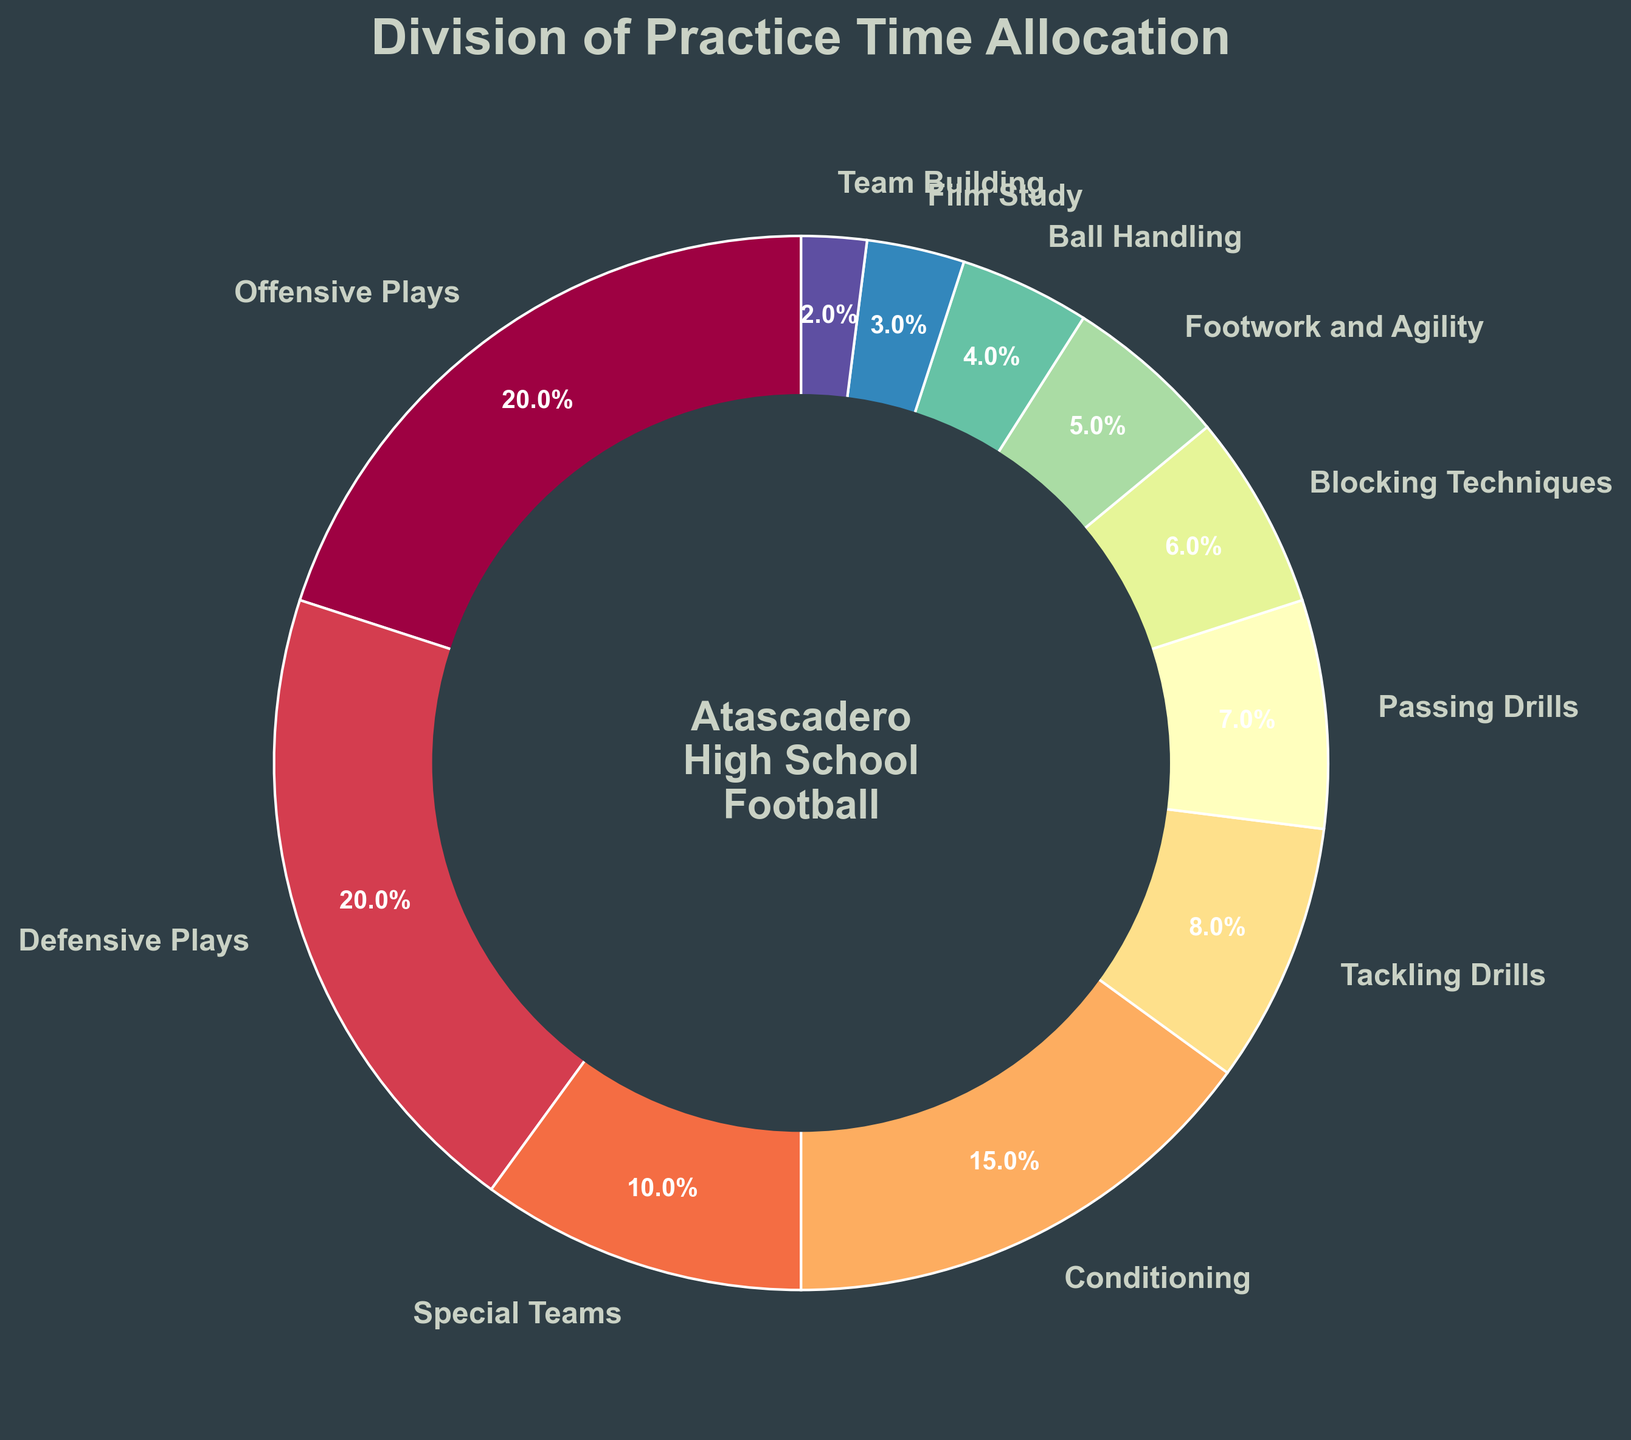What's the total percentage allocated to offensive and defensive plays? Add the percentages for Offensive Plays (20%) and Defensive Plays (20%). 20% + 20% = 40%
Answer: 40% Which skill has the smallest allocation of practice time? Look for the skill with the smallest percentage in the pie chart. Team Building has the smallest allocation at 2%.
Answer: Team Building What is the difference in practice time between Conditioning and Passing Drills? Subtract the percentage of Passing Drills (7%) from the percentage of Conditioning (15%). 15% - 7% = 8%
Answer: 8% Which two skills have an equal allocation of practice time? Compare the percentages of the skills in the pie chart to find any that are equal. Offensive Plays and Defensive Plays both have 20%.
Answer: Offensive Plays and Defensive Plays How much more practice time is given to Tackling Drills than Ball Handling? Subtract the percentage of Ball Handling (4%) from the percentage of Tackling Drills (8%). 8% - 4% = 4%
Answer: 4% What is the combined percentage for Special Teams, Blocking Techniques, and Footwork and Agility? Add the percentages for Special Teams (10%), Blocking Techniques (6%), and Footwork and Agility (5%). 10% + 6% + 5% = 21%
Answer: 21% Which skill is allocated more practice time: Film Study or Team Building? Compare the percentages of Film Study (3%) and Team Building (2%). Film Study has more practice time.
Answer: Film Study What percentage more practice time is allocated to Conditioning compared to Footwork and Agility? Subtract the percentage of Footwork and Agility (5%) from the percentage of Conditioning (15%) and calculate the difference. 15% - 5% = 10%
Answer: 10% If we combined time allocated to Offensive Plays, Defensive Plays, and Special Teams, what would be the total practice time percentage? Add the percentages for Offensive Plays (20%), Defensive Plays (20%), and Special Teams (10%). 20% + 20% + 10% = 50%
Answer: 50% Which skill category uses the most visually distinctive color in the pie chart? The pie chart uses a spectrum of colors. Identify the category with the most visually distinct color by observing the color variations. Typically, colors at the extremes of the spectrum (like dark red or bright blue) are most visually distinctive. This requires a subjective judgment based on visual appeal.
Answer: (Subjective: Based on the spectrum ranging from dark to light shades, typically Offensive Plays or Special Teams may have the most distinct color based on the plot's color scheme) 